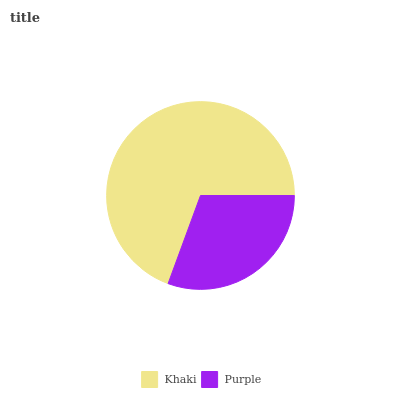Is Purple the minimum?
Answer yes or no. Yes. Is Khaki the maximum?
Answer yes or no. Yes. Is Purple the maximum?
Answer yes or no. No. Is Khaki greater than Purple?
Answer yes or no. Yes. Is Purple less than Khaki?
Answer yes or no. Yes. Is Purple greater than Khaki?
Answer yes or no. No. Is Khaki less than Purple?
Answer yes or no. No. Is Khaki the high median?
Answer yes or no. Yes. Is Purple the low median?
Answer yes or no. Yes. Is Purple the high median?
Answer yes or no. No. Is Khaki the low median?
Answer yes or no. No. 